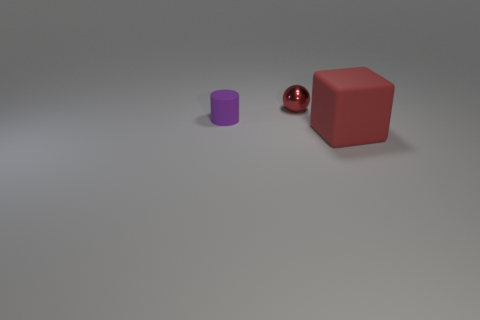What number of big cubes are there?
Give a very brief answer. 1. There is a tiny thing behind the purple cylinder; does it have the same shape as the big red matte thing?
Provide a succinct answer. No. There is a purple cylinder that is the same size as the metallic sphere; what is its material?
Your answer should be compact. Rubber. Is there another ball that has the same material as the small ball?
Make the answer very short. No. Does the small red metal object have the same shape as the thing in front of the purple cylinder?
Make the answer very short. No. How many objects are right of the purple thing and behind the large block?
Make the answer very short. 1. Is the ball made of the same material as the large object that is in front of the small purple object?
Provide a succinct answer. No. Is the number of large red rubber cubes that are on the left side of the small shiny thing the same as the number of tiny purple rubber things?
Your answer should be very brief. No. The small object on the right side of the purple cylinder is what color?
Offer a very short reply. Red. How many other things are there of the same color as the cylinder?
Your response must be concise. 0. 